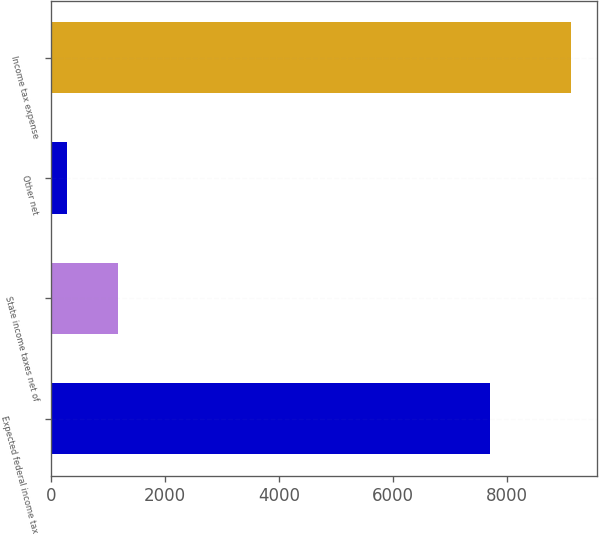<chart> <loc_0><loc_0><loc_500><loc_500><bar_chart><fcel>Expected federal income tax<fcel>State income taxes net of<fcel>Other net<fcel>Income tax expense<nl><fcel>7709<fcel>1166<fcel>281<fcel>9131<nl></chart> 